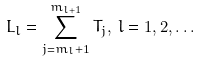Convert formula to latex. <formula><loc_0><loc_0><loc_500><loc_500>L _ { l } = \sum _ { j = m _ { l } + 1 } ^ { m _ { l + 1 } } T _ { j } , \, l = 1 , 2 , \dots</formula> 